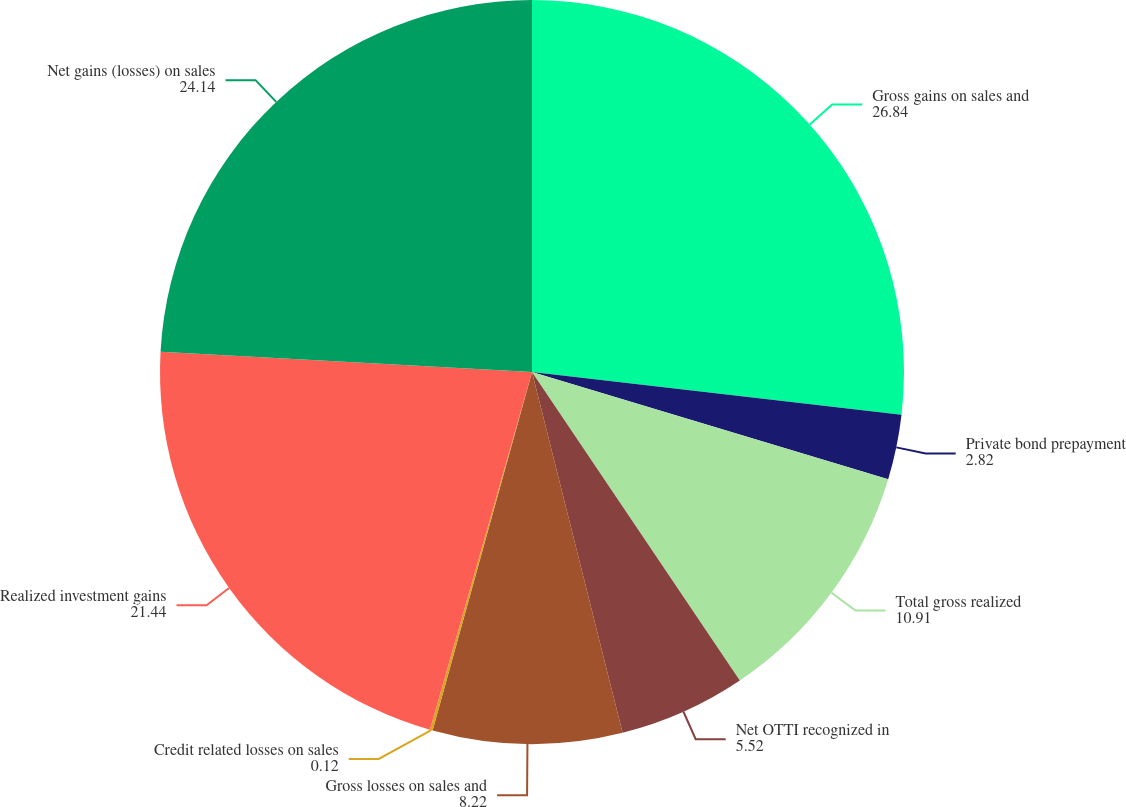Convert chart to OTSL. <chart><loc_0><loc_0><loc_500><loc_500><pie_chart><fcel>Gross gains on sales and<fcel>Private bond prepayment<fcel>Total gross realized<fcel>Net OTTI recognized in<fcel>Gross losses on sales and<fcel>Credit related losses on sales<fcel>Realized investment gains<fcel>Net gains (losses) on sales<nl><fcel>26.84%<fcel>2.82%<fcel>10.91%<fcel>5.52%<fcel>8.22%<fcel>0.12%<fcel>21.44%<fcel>24.14%<nl></chart> 